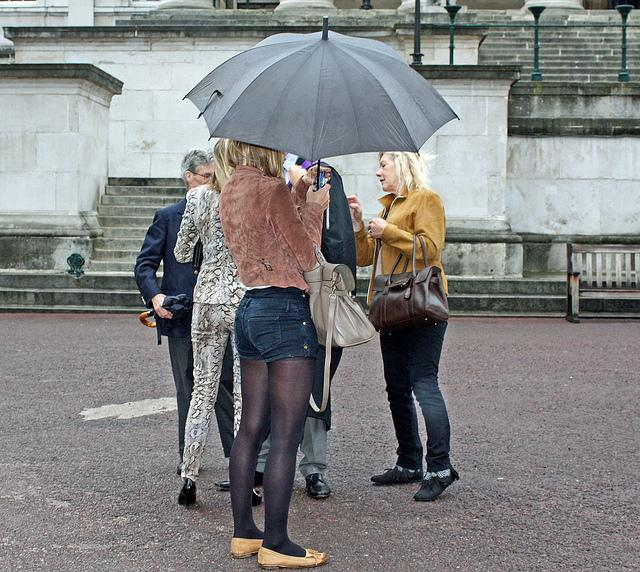From what materials is the wall made?

Choices:
A) blocks
B) wood
C) tile
D) bricks blocks 